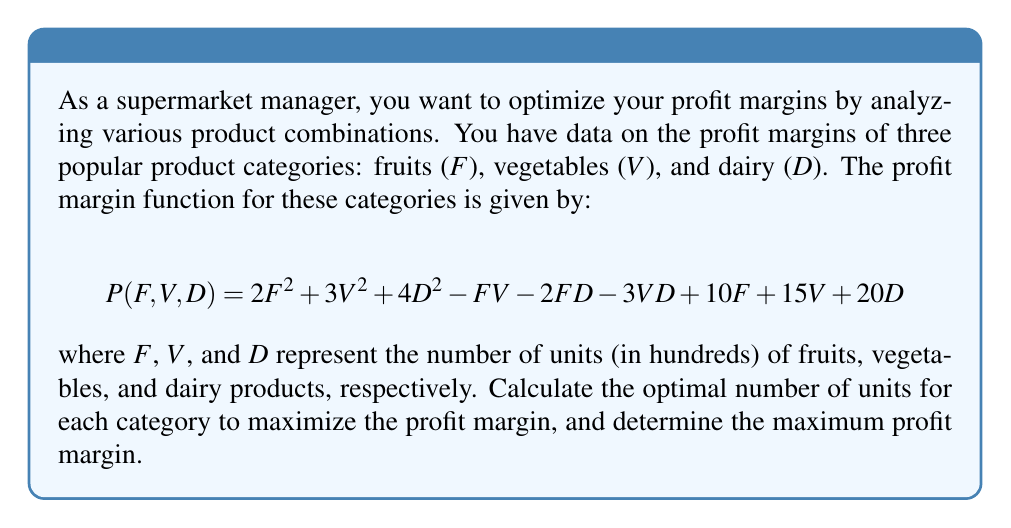What is the answer to this math problem? To find the optimal number of units for each category and the maximum profit margin, we need to use multivariate calculus. We'll follow these steps:

1. Find the partial derivatives of $P$ with respect to $F$, $V$, and $D$.
2. Set each partial derivative equal to zero to find the critical points.
3. Solve the system of equations to find the optimal values.
4. Calculate the maximum profit margin using the optimal values.

Step 1: Partial derivatives

$$\frac{\partial P}{\partial F} = 4F - V - 2D + 10$$
$$\frac{\partial P}{\partial V} = 6V - F - 3D + 15$$
$$\frac{\partial P}{\partial D} = 8D - 2F - 3V + 20$$

Step 2: Set partial derivatives to zero

$$4F - V - 2D + 10 = 0$$
$$6V - F - 3D + 15 = 0$$
$$8D - 2F - 3V + 20 = 0$$

Step 3: Solve the system of equations

We can solve this system using substitution or matrix methods. After solving, we get:

$$F = 5$$
$$V = 5$$
$$D = 5$$

Step 4: Calculate the maximum profit margin

Substitute the optimal values into the original profit margin function:

$$\begin{align*}
P(5, 5, 5) &= 2(5^2) + 3(5^2) + 4(5^2) - 5(5) - 2(5)(5) - 3(5)(5) + 10(5) + 15(5) + 20(5) \\
&= 50 + 75 + 100 - 25 - 50 - 75 + 50 + 75 + 100 \\
&= 300
\end{align*}$$

Therefore, the maximum profit margin is 300 (which represents $30,000 since we were working in hundreds of units).
Answer: The optimal number of units for each category is 500 units of fruits, 500 units of vegetables, and 500 units of dairy products. The maximum profit margin is $30,000. 